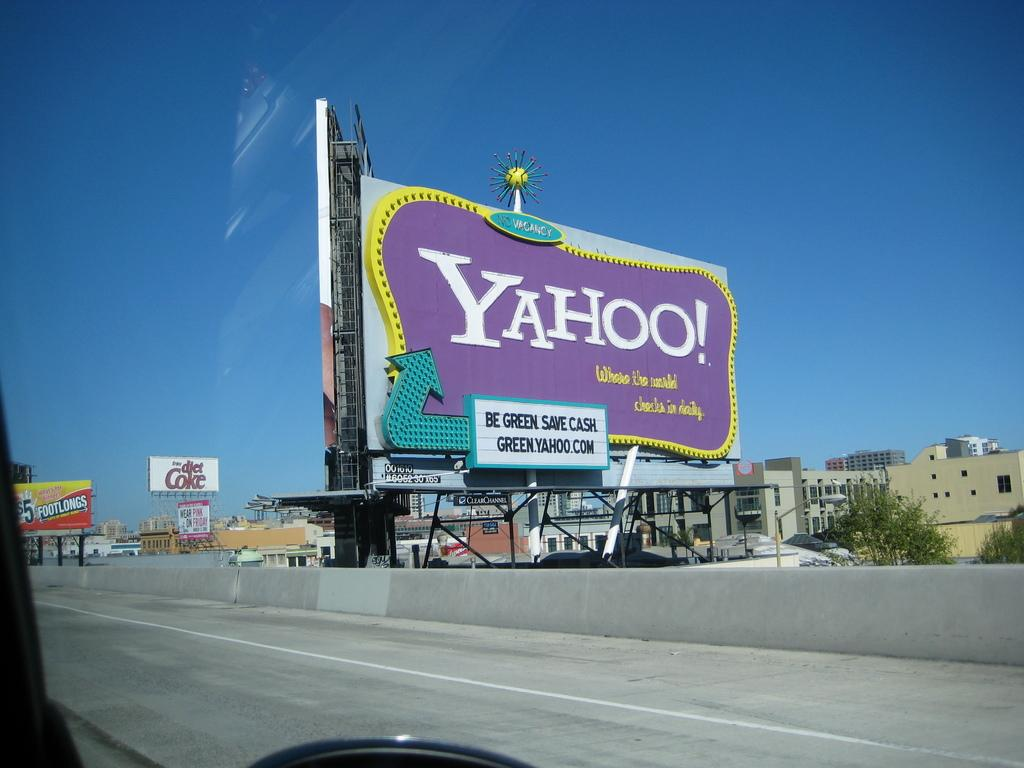<image>
Provide a brief description of the given image. a billboard for Yahoo reads "Be Green, Save Cash" 